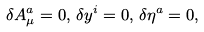Convert formula to latex. <formula><loc_0><loc_0><loc_500><loc_500>\delta A _ { \mu } ^ { a } = 0 , \, \delta y ^ { i } = 0 , \, \delta \eta ^ { a } = 0 ,</formula> 